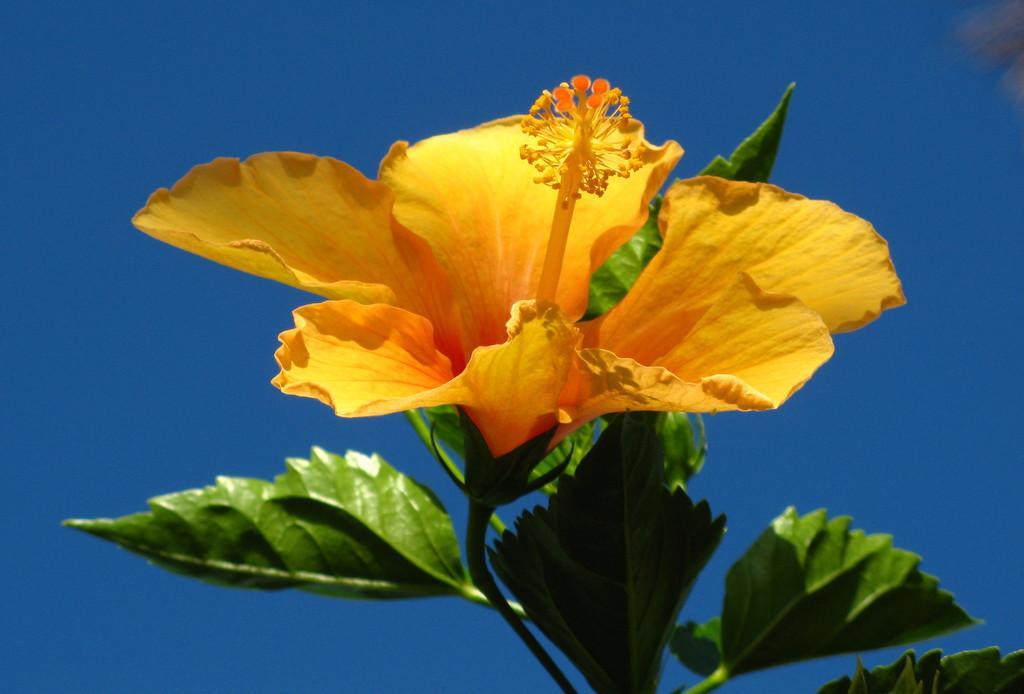Describe this image in one or two sentences. In this picture I can see a flower, there are leaves, and in the background there is the sky. 